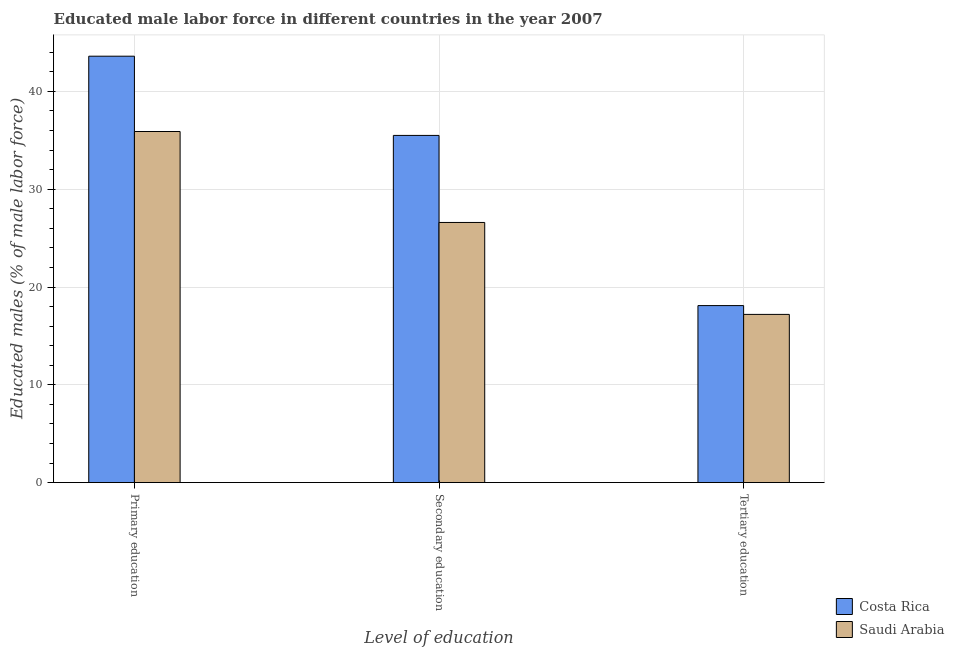How many groups of bars are there?
Your response must be concise. 3. Are the number of bars per tick equal to the number of legend labels?
Your answer should be very brief. Yes. Are the number of bars on each tick of the X-axis equal?
Make the answer very short. Yes. What is the label of the 3rd group of bars from the left?
Give a very brief answer. Tertiary education. What is the percentage of male labor force who received secondary education in Saudi Arabia?
Offer a very short reply. 26.6. Across all countries, what is the maximum percentage of male labor force who received primary education?
Keep it short and to the point. 43.6. Across all countries, what is the minimum percentage of male labor force who received primary education?
Ensure brevity in your answer.  35.9. In which country was the percentage of male labor force who received primary education maximum?
Offer a very short reply. Costa Rica. In which country was the percentage of male labor force who received primary education minimum?
Offer a very short reply. Saudi Arabia. What is the total percentage of male labor force who received tertiary education in the graph?
Keep it short and to the point. 35.3. What is the difference between the percentage of male labor force who received tertiary education in Saudi Arabia and that in Costa Rica?
Provide a short and direct response. -0.9. What is the difference between the percentage of male labor force who received secondary education in Costa Rica and the percentage of male labor force who received primary education in Saudi Arabia?
Provide a short and direct response. -0.4. What is the average percentage of male labor force who received tertiary education per country?
Your answer should be very brief. 17.65. What is the difference between the percentage of male labor force who received secondary education and percentage of male labor force who received primary education in Saudi Arabia?
Your answer should be compact. -9.3. What is the ratio of the percentage of male labor force who received primary education in Costa Rica to that in Saudi Arabia?
Your answer should be very brief. 1.21. Is the percentage of male labor force who received primary education in Costa Rica less than that in Saudi Arabia?
Provide a short and direct response. No. What is the difference between the highest and the second highest percentage of male labor force who received primary education?
Your response must be concise. 7.7. What is the difference between the highest and the lowest percentage of male labor force who received primary education?
Give a very brief answer. 7.7. In how many countries, is the percentage of male labor force who received tertiary education greater than the average percentage of male labor force who received tertiary education taken over all countries?
Your response must be concise. 1. What does the 1st bar from the left in Secondary education represents?
Provide a short and direct response. Costa Rica. How many bars are there?
Your answer should be very brief. 6. What is the difference between two consecutive major ticks on the Y-axis?
Provide a short and direct response. 10. Are the values on the major ticks of Y-axis written in scientific E-notation?
Your answer should be compact. No. What is the title of the graph?
Offer a terse response. Educated male labor force in different countries in the year 2007. Does "Malaysia" appear as one of the legend labels in the graph?
Provide a short and direct response. No. What is the label or title of the X-axis?
Your response must be concise. Level of education. What is the label or title of the Y-axis?
Ensure brevity in your answer.  Educated males (% of male labor force). What is the Educated males (% of male labor force) of Costa Rica in Primary education?
Your answer should be very brief. 43.6. What is the Educated males (% of male labor force) in Saudi Arabia in Primary education?
Offer a terse response. 35.9. What is the Educated males (% of male labor force) in Costa Rica in Secondary education?
Offer a very short reply. 35.5. What is the Educated males (% of male labor force) in Saudi Arabia in Secondary education?
Provide a short and direct response. 26.6. What is the Educated males (% of male labor force) of Costa Rica in Tertiary education?
Ensure brevity in your answer.  18.1. What is the Educated males (% of male labor force) in Saudi Arabia in Tertiary education?
Offer a terse response. 17.2. Across all Level of education, what is the maximum Educated males (% of male labor force) of Costa Rica?
Keep it short and to the point. 43.6. Across all Level of education, what is the maximum Educated males (% of male labor force) in Saudi Arabia?
Give a very brief answer. 35.9. Across all Level of education, what is the minimum Educated males (% of male labor force) of Costa Rica?
Offer a very short reply. 18.1. Across all Level of education, what is the minimum Educated males (% of male labor force) of Saudi Arabia?
Your response must be concise. 17.2. What is the total Educated males (% of male labor force) in Costa Rica in the graph?
Provide a short and direct response. 97.2. What is the total Educated males (% of male labor force) in Saudi Arabia in the graph?
Keep it short and to the point. 79.7. What is the difference between the Educated males (% of male labor force) of Costa Rica in Primary education and that in Secondary education?
Provide a short and direct response. 8.1. What is the difference between the Educated males (% of male labor force) of Saudi Arabia in Primary education and that in Secondary education?
Offer a very short reply. 9.3. What is the difference between the Educated males (% of male labor force) in Saudi Arabia in Primary education and that in Tertiary education?
Offer a very short reply. 18.7. What is the difference between the Educated males (% of male labor force) of Costa Rica in Secondary education and that in Tertiary education?
Your answer should be compact. 17.4. What is the difference between the Educated males (% of male labor force) of Saudi Arabia in Secondary education and that in Tertiary education?
Ensure brevity in your answer.  9.4. What is the difference between the Educated males (% of male labor force) of Costa Rica in Primary education and the Educated males (% of male labor force) of Saudi Arabia in Tertiary education?
Offer a very short reply. 26.4. What is the difference between the Educated males (% of male labor force) in Costa Rica in Secondary education and the Educated males (% of male labor force) in Saudi Arabia in Tertiary education?
Your answer should be compact. 18.3. What is the average Educated males (% of male labor force) of Costa Rica per Level of education?
Offer a terse response. 32.4. What is the average Educated males (% of male labor force) of Saudi Arabia per Level of education?
Your response must be concise. 26.57. What is the difference between the Educated males (% of male labor force) of Costa Rica and Educated males (% of male labor force) of Saudi Arabia in Primary education?
Keep it short and to the point. 7.7. What is the difference between the Educated males (% of male labor force) in Costa Rica and Educated males (% of male labor force) in Saudi Arabia in Secondary education?
Ensure brevity in your answer.  8.9. What is the ratio of the Educated males (% of male labor force) in Costa Rica in Primary education to that in Secondary education?
Provide a succinct answer. 1.23. What is the ratio of the Educated males (% of male labor force) of Saudi Arabia in Primary education to that in Secondary education?
Keep it short and to the point. 1.35. What is the ratio of the Educated males (% of male labor force) of Costa Rica in Primary education to that in Tertiary education?
Ensure brevity in your answer.  2.41. What is the ratio of the Educated males (% of male labor force) in Saudi Arabia in Primary education to that in Tertiary education?
Provide a short and direct response. 2.09. What is the ratio of the Educated males (% of male labor force) in Costa Rica in Secondary education to that in Tertiary education?
Offer a terse response. 1.96. What is the ratio of the Educated males (% of male labor force) in Saudi Arabia in Secondary education to that in Tertiary education?
Provide a succinct answer. 1.55. What is the difference between the highest and the second highest Educated males (% of male labor force) in Saudi Arabia?
Give a very brief answer. 9.3. What is the difference between the highest and the lowest Educated males (% of male labor force) of Costa Rica?
Provide a short and direct response. 25.5. 